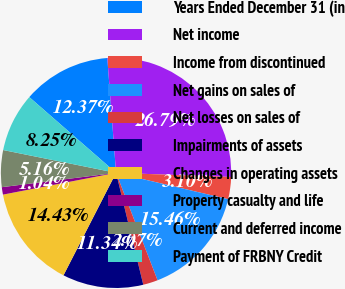Convert chart. <chart><loc_0><loc_0><loc_500><loc_500><pie_chart><fcel>Years Ended December 31 (in<fcel>Net income<fcel>Income from discontinued<fcel>Net gains on sales of<fcel>Net losses on sales of<fcel>Impairments of assets<fcel>Changes in operating assets<fcel>Property casualty and life<fcel>Current and deferred income<fcel>Payment of FRBNY Credit<nl><fcel>12.37%<fcel>26.79%<fcel>3.1%<fcel>15.46%<fcel>2.07%<fcel>11.34%<fcel>14.43%<fcel>1.04%<fcel>5.16%<fcel>8.25%<nl></chart> 